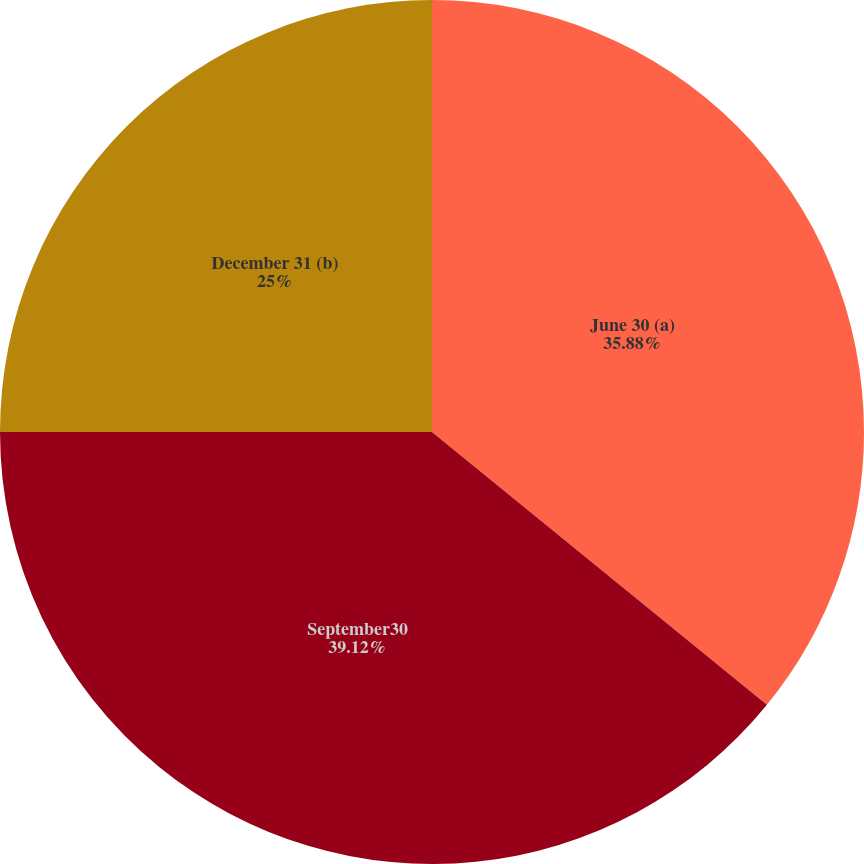Convert chart to OTSL. <chart><loc_0><loc_0><loc_500><loc_500><pie_chart><fcel>June 30 (a)<fcel>September30<fcel>December 31 (b)<nl><fcel>35.88%<fcel>39.12%<fcel>25.0%<nl></chart> 